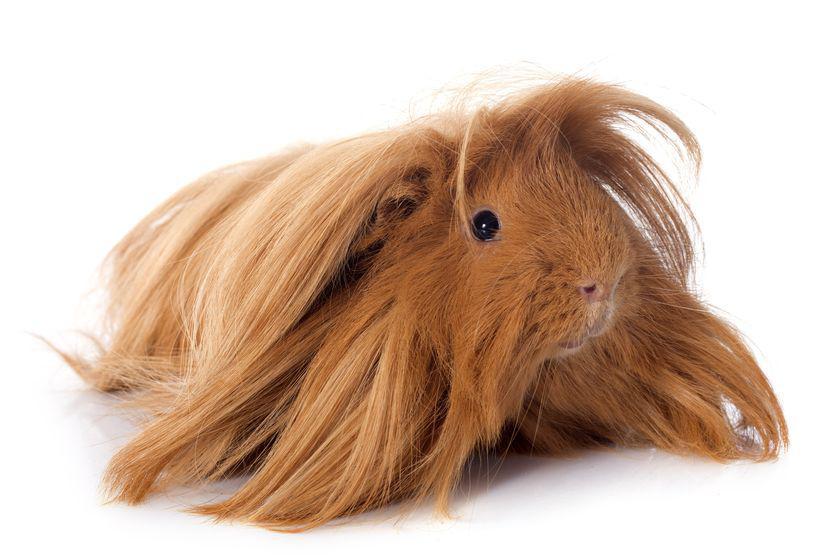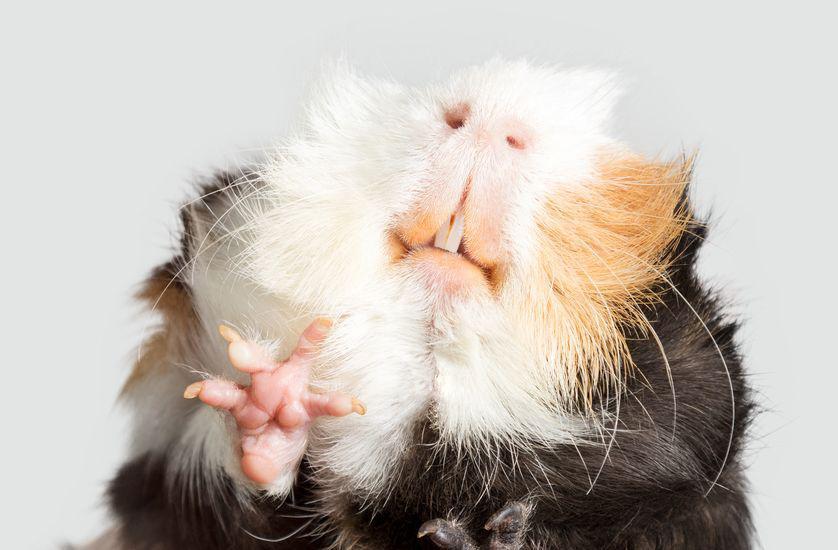The first image is the image on the left, the second image is the image on the right. Assess this claim about the two images: "There is at least one animal whose eyes you cannot see at all.". Correct or not? Answer yes or no. Yes. The first image is the image on the left, the second image is the image on the right. For the images shown, is this caption "One of the images shows a gerbil whose eyes are not visible." true? Answer yes or no. Yes. 